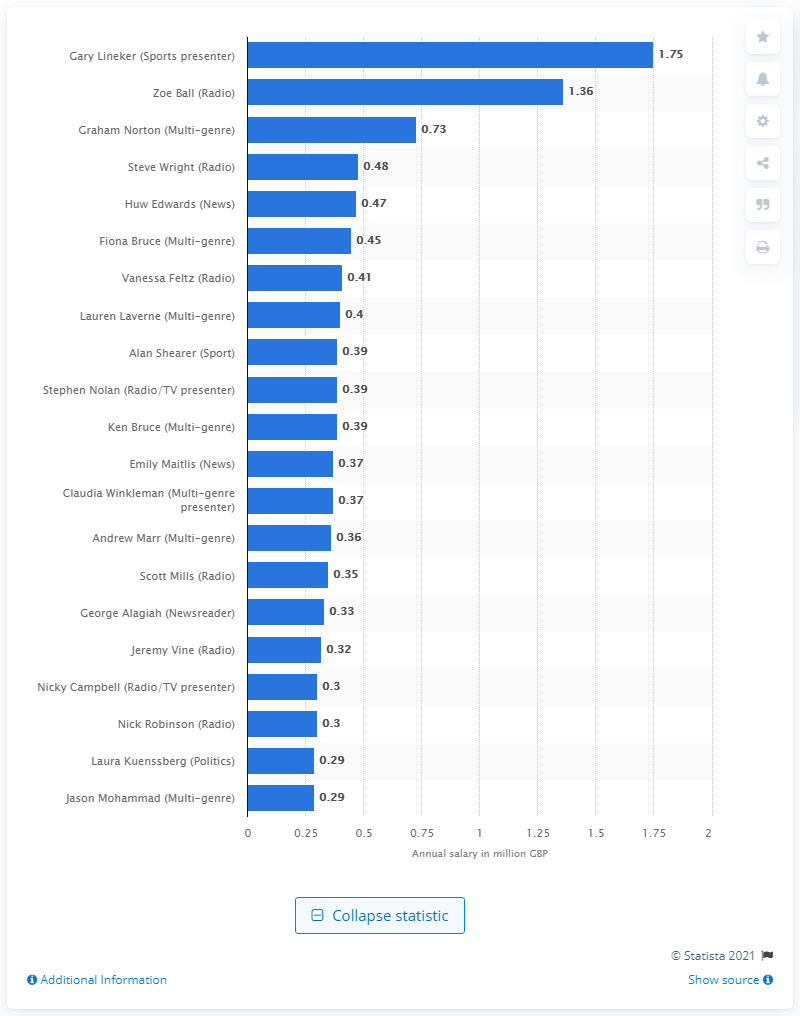Give some essential details in this illustration. Gary Lineker earned 1.75 million pounds. 